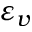<formula> <loc_0><loc_0><loc_500><loc_500>\varepsilon _ { v }</formula> 